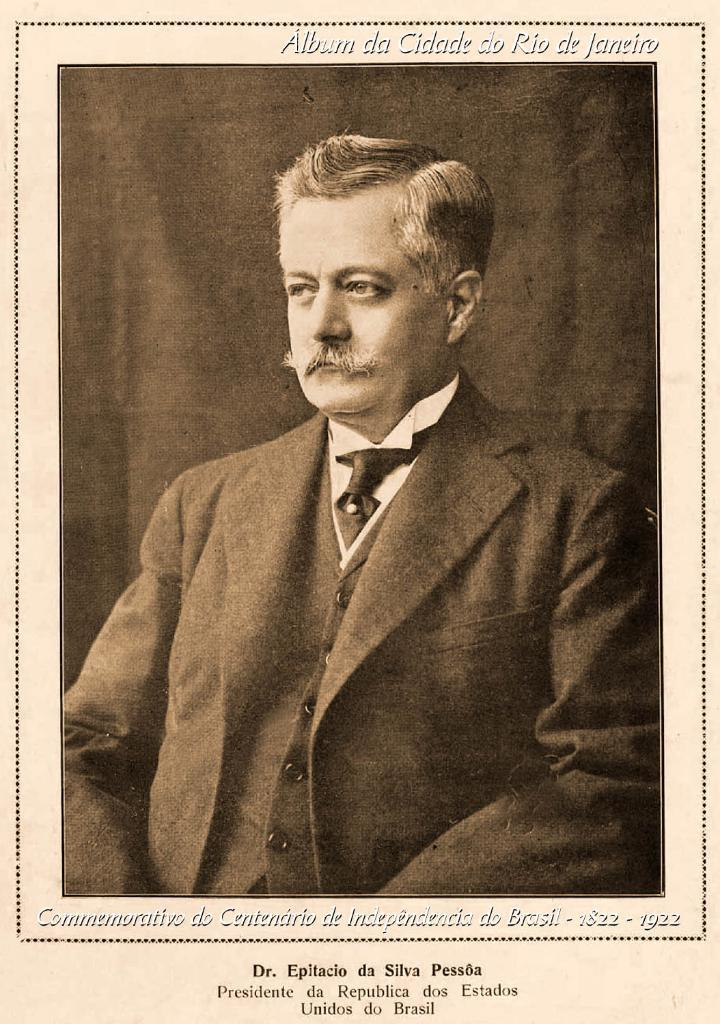Who or what is the main subject of the image? There is a person in the image. What is the person wearing in the image? The person is wearing a coat and a tie. What is the color scheme of the image? The image is in black and white. What type of education does the person in the image have? There is no information about the person's education in the image. What is the person arguing about in the image? There is no argument or discussion taking place in the image. 